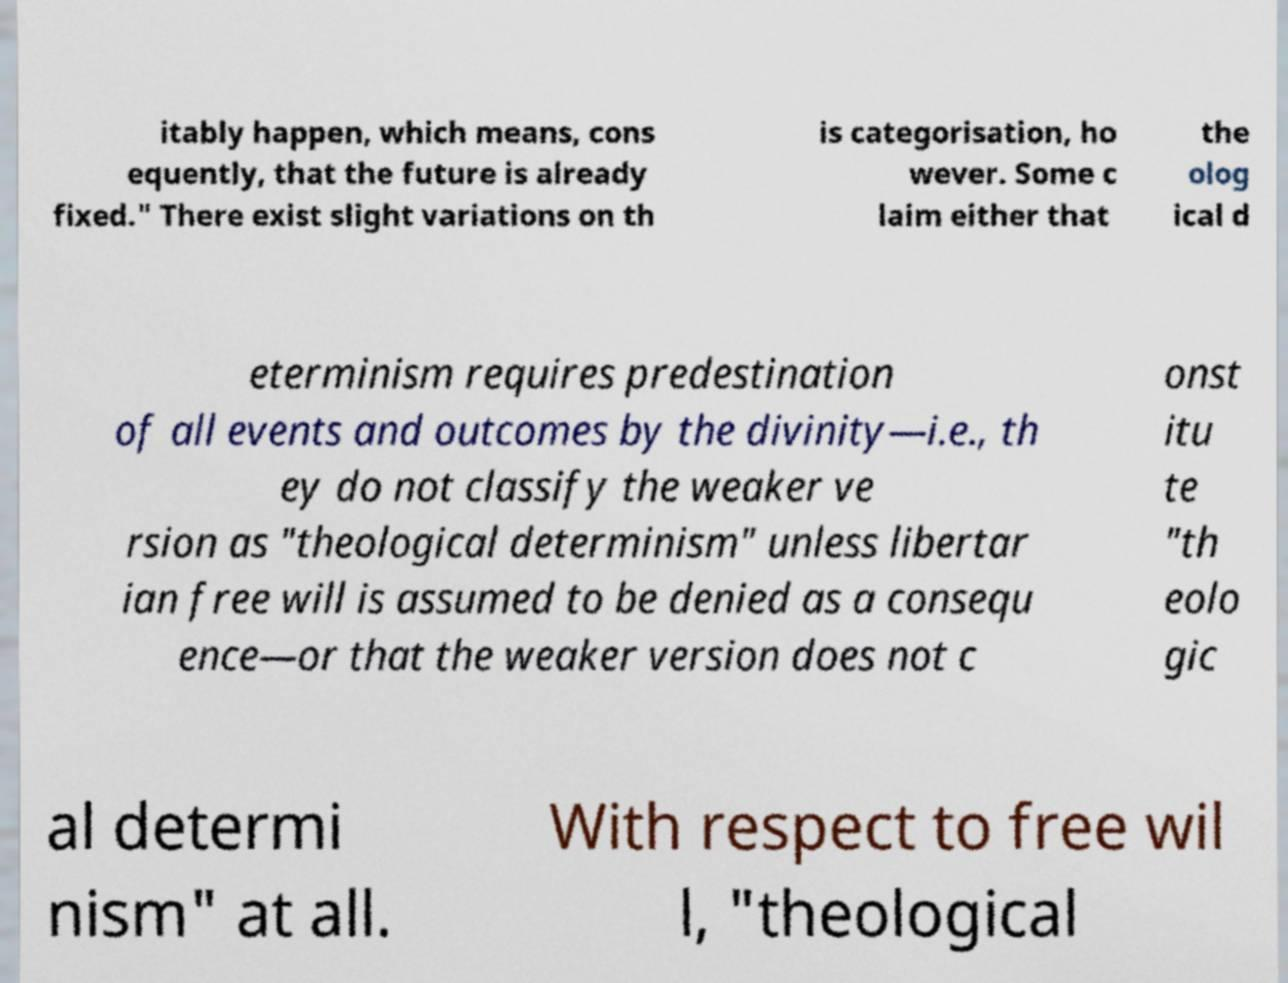Could you assist in decoding the text presented in this image and type it out clearly? itably happen, which means, cons equently, that the future is already fixed." There exist slight variations on th is categorisation, ho wever. Some c laim either that the olog ical d eterminism requires predestination of all events and outcomes by the divinity—i.e., th ey do not classify the weaker ve rsion as "theological determinism" unless libertar ian free will is assumed to be denied as a consequ ence—or that the weaker version does not c onst itu te "th eolo gic al determi nism" at all. With respect to free wil l, "theological 